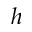Convert formula to latex. <formula><loc_0><loc_0><loc_500><loc_500>h</formula> 